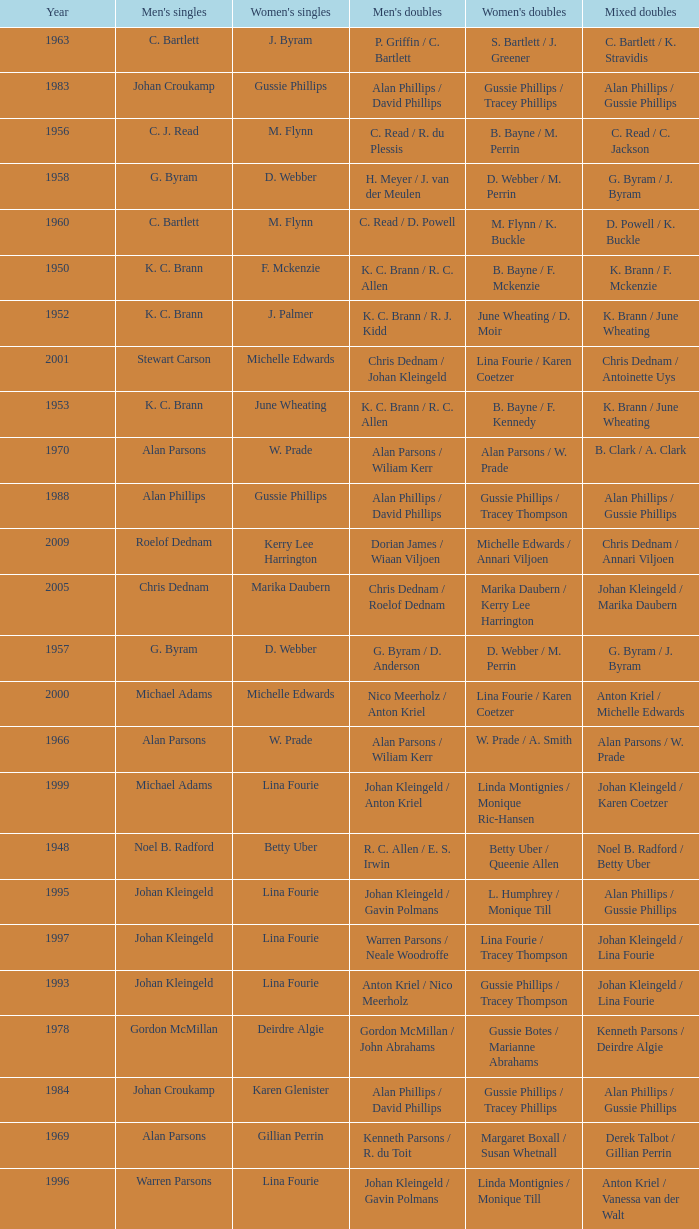Which Men's doubles have a Year smaller than 1960, and Men's singles of noel b. radford? R. C. Allen / E. S. Irwin. 